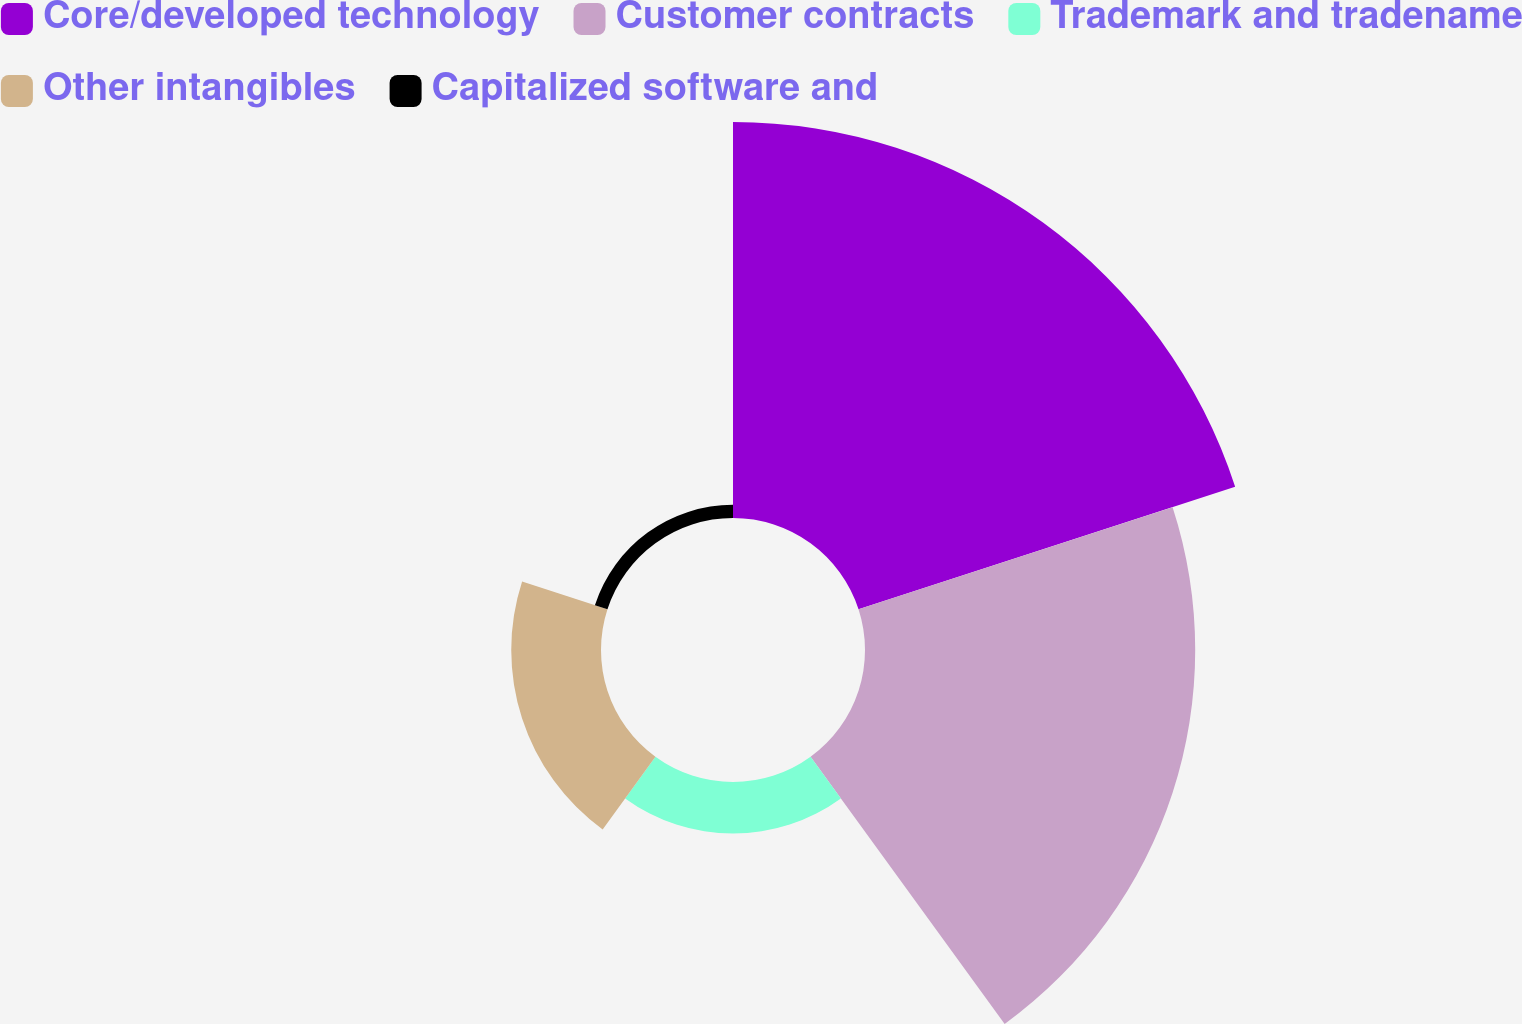Convert chart. <chart><loc_0><loc_0><loc_500><loc_500><pie_chart><fcel>Core/developed technology<fcel>Customer contracts<fcel>Trademark and tradename<fcel>Other intangibles<fcel>Capitalized software and<nl><fcel>44.96%<fcel>37.49%<fcel>5.85%<fcel>10.19%<fcel>1.5%<nl></chart> 